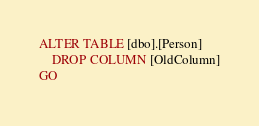<code> <loc_0><loc_0><loc_500><loc_500><_SQL_>ALTER TABLE [dbo].[Person]
    DROP COLUMN [OldColumn]
GO</code> 